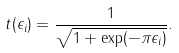Convert formula to latex. <formula><loc_0><loc_0><loc_500><loc_500>t ( \epsilon _ { i } ) = \frac { 1 } { \sqrt { 1 + \exp ( - \pi \epsilon _ { i } ) } } .</formula> 